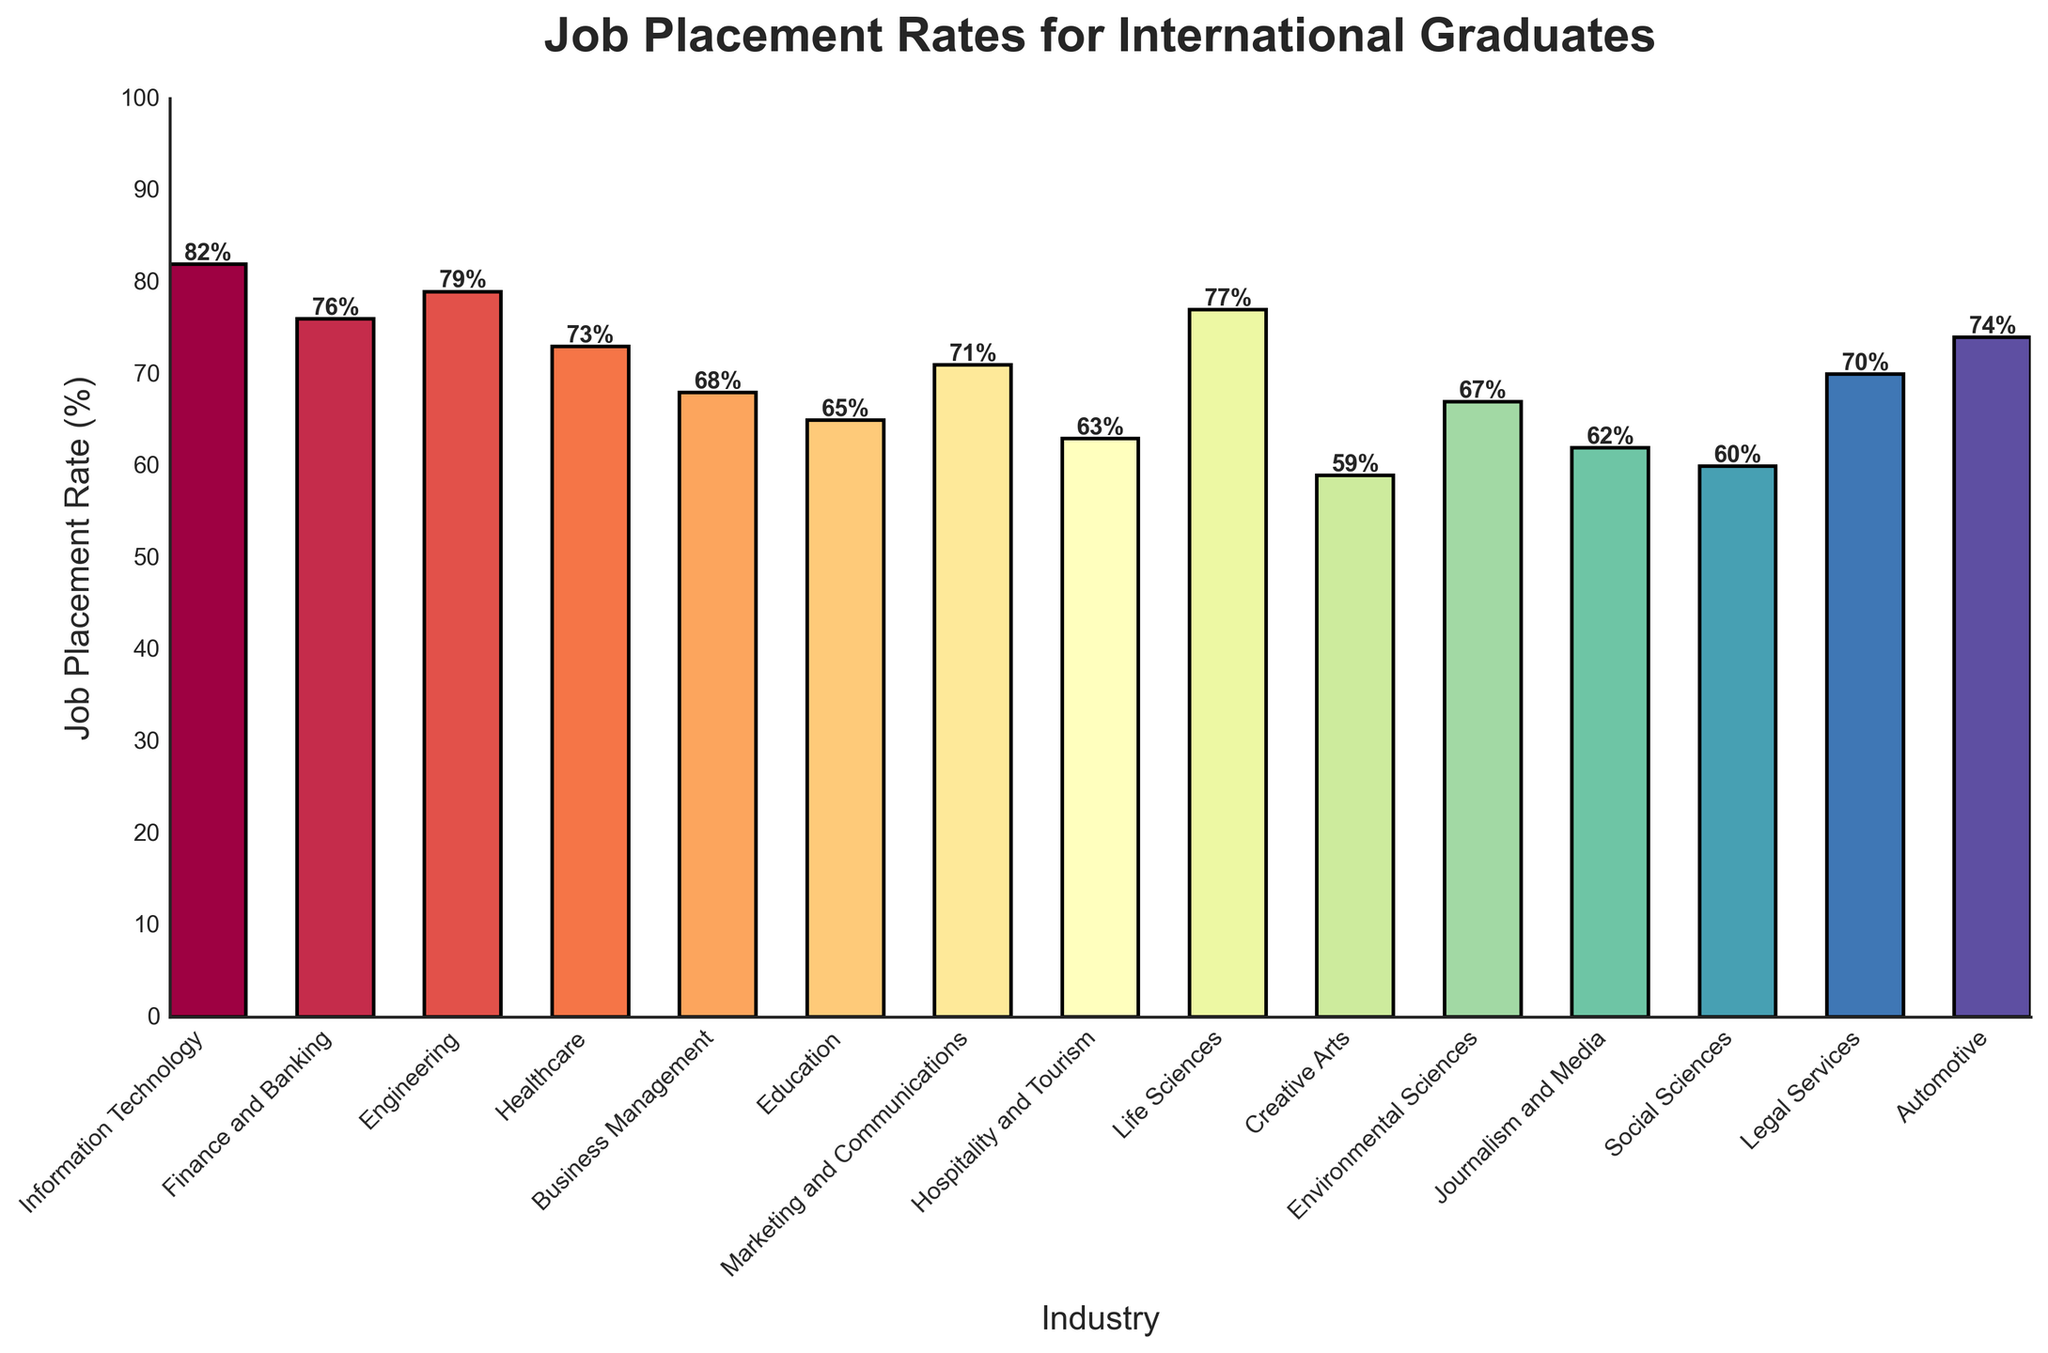What industry has the highest job placement rate for international graduates? Identify the tallest bar in the plot, representing the highest job placement rate.
Answer: Information Technology Which industry has the lowest job placement rate for international graduates? Identify the shortest bar in the plot, representing the lowest job placement rate.
Answer: Creative Arts What is the difference in job placement rates between Finance and Banking and Business Management? Find the heights of the bars for Finance and Banking and Business Management, then subtract the job placement rate of Business Management (68) from Finance and Banking (76).
Answer: 8 Which industry has a higher job placement rate: Healthcare or Marketing and Communications? Compare the heights of the bars for Healthcare (73) and Marketing and Communications (71).
Answer: Healthcare What is the combined job placement rate for Engineering, Life Sciences, and Automotive industries? Add the job placement rates of Engineering (79), Life Sciences (77), and Automotive (74). 79 + 77 + 74 = 230
Answer: 230 Which two industries have the closest job placement rates? Compare the placement rates of all industries and find the two with the smallest difference.
Answer: Journalism and Media and Social Sciences How many industries have a job placement rate above 70%? Count all the bars with heights above the 70% mark.
Answer: 8 What is the average job placement rate for the top five industries? Identify the top 5 industries with the highest placement rates and then calculate the average. (82 + 79 + 77 + 76 + 74) / 5 = 388 / 5 = 77.6
Answer: 77.6 What is the total job placement rate for industries starting with the letter 'E'? Add the job placement rates for Education, Environmental Sciences, and Engineering. (65 + 67 + 79) = 211
Answer: 211 Which has a higher job placement rate, the average of Healthcare and Business Management or Legal Services? Calculate the average of Healthcare (73) and Business Management (68), (73 + 68)/2 = 70.5, and compare it with Legal Services (70).
Answer: Healthcare and Business Management 